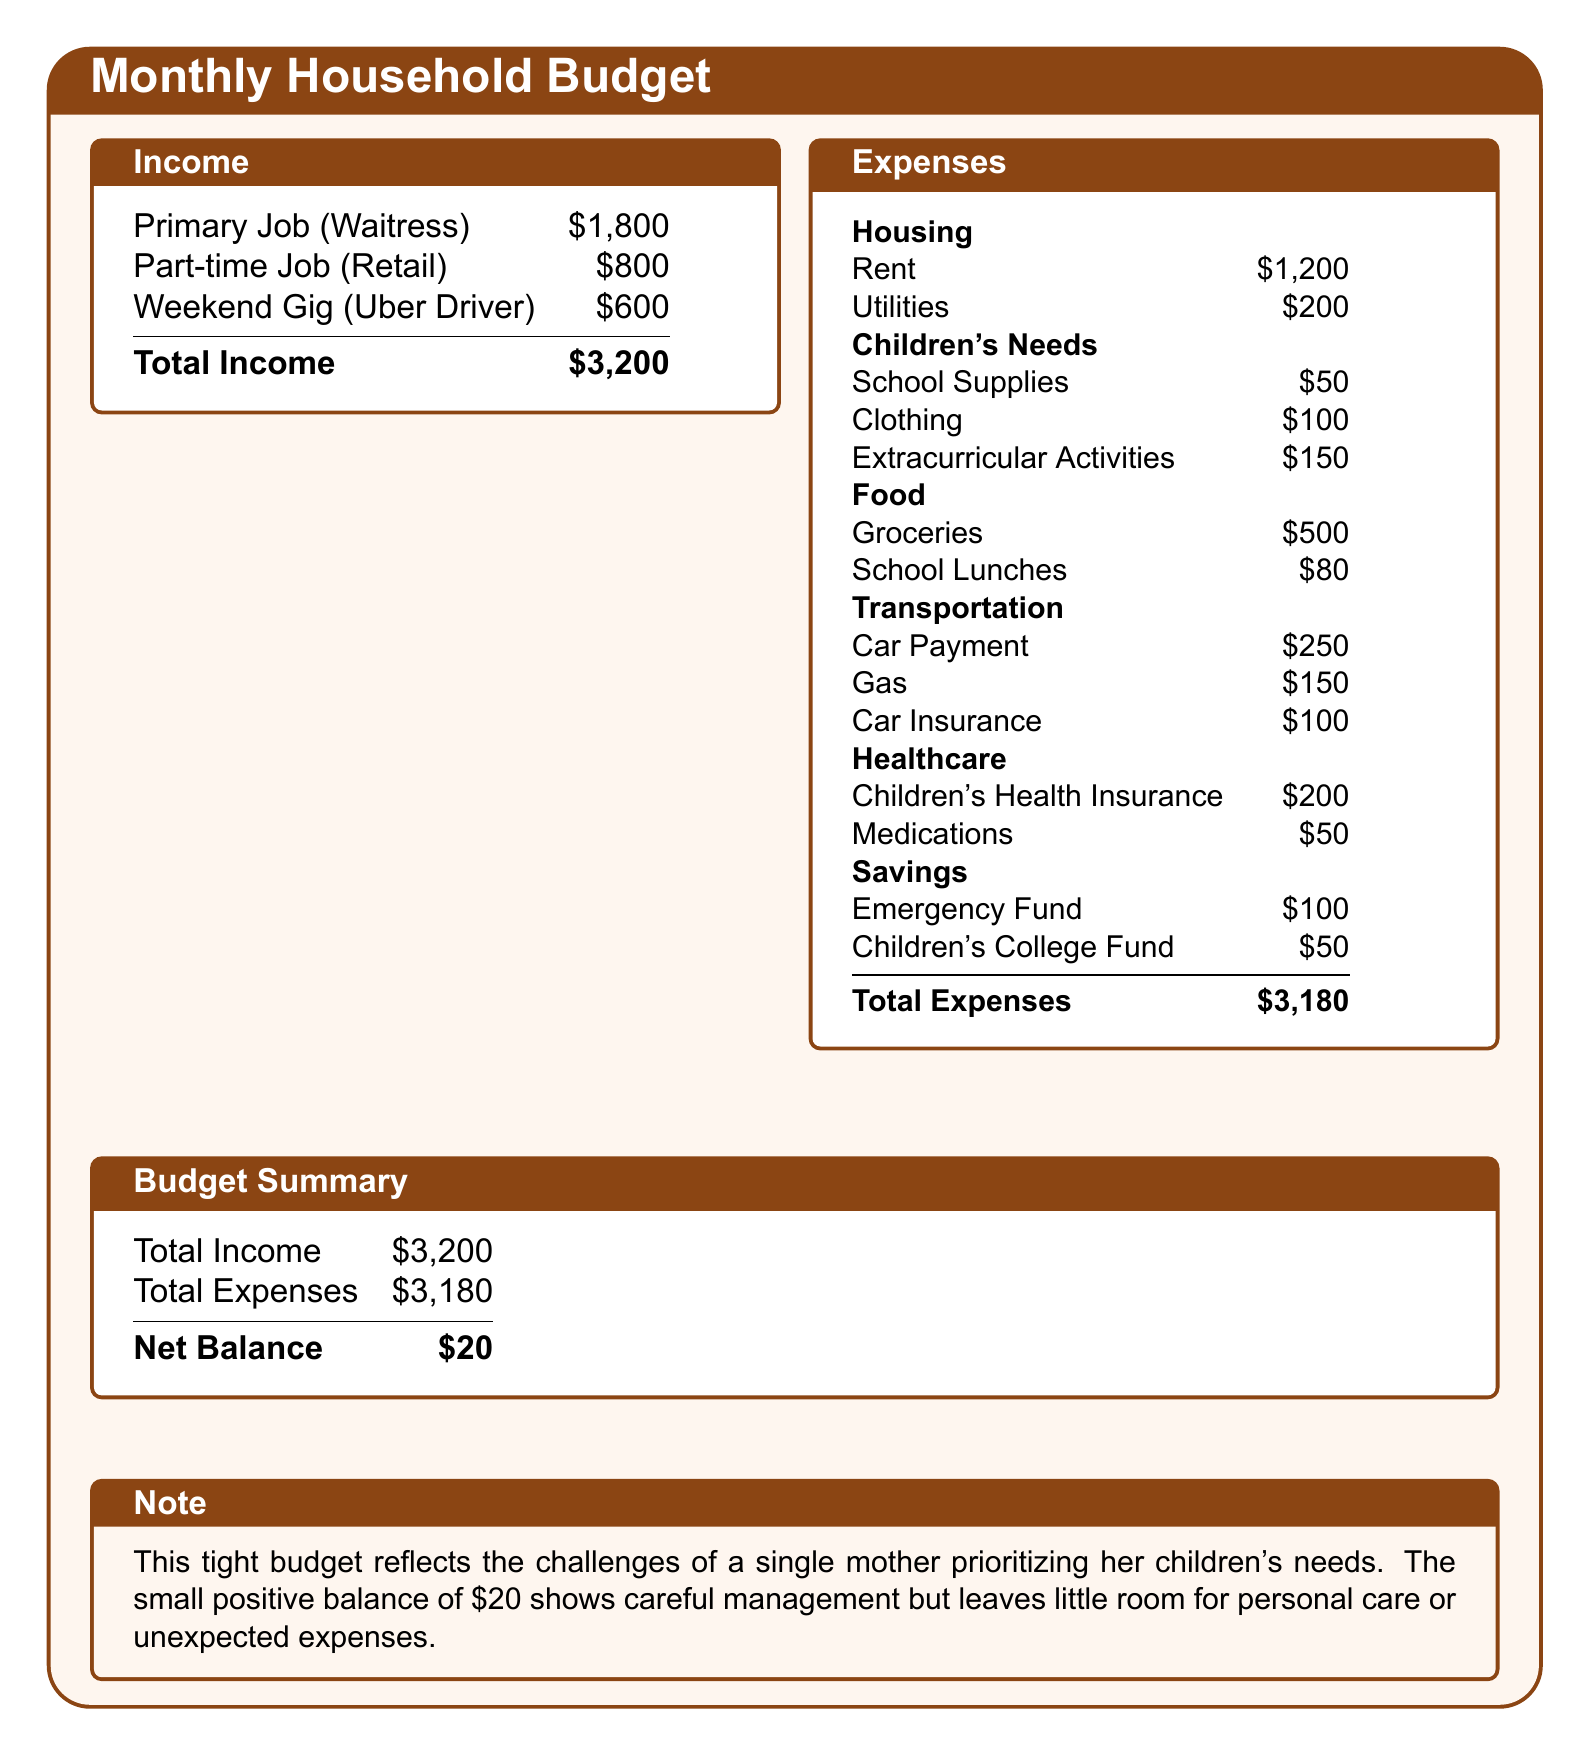what is the total income? The total income is the sum of all income sources listed in the document, which is $1,800 + $800 + $600 = $3,200.
Answer: $3,200 what is the largest expense category? The largest expense category is housing, which includes rent and utilities.
Answer: Housing how much is spent on groceries? The document states that groceries cost $500 per month.
Answer: $500 what is the net balance of the budget? The net balance is the difference between total income and total expenses, which is $3,200 - $3,180 = $20.
Answer: $20 how much does the children's college fund receive? The children's college fund allocation is noted as $50 per month in the expenses section.
Answer: $50 what is the total amount spent on children's needs? The total amount spent on children's needs can be calculated by adding school supplies, clothing, and extracurricular activities, which is $50 + $100 + $150 = $300.
Answer: $300 how much is allocated for healthcare expenses? The total healthcare expenses include children's health insurance and medications, which is $200 + $50 = $250.
Answer: $250 what is the combined cost of transportation? Transportation costs consist of car payment, gas, and car insurance, totaling $250 + $150 + $100 = $500.
Answer: $500 how much is spent on school lunches? The expense for school lunches is stated as $80 in the document.
Answer: $80 